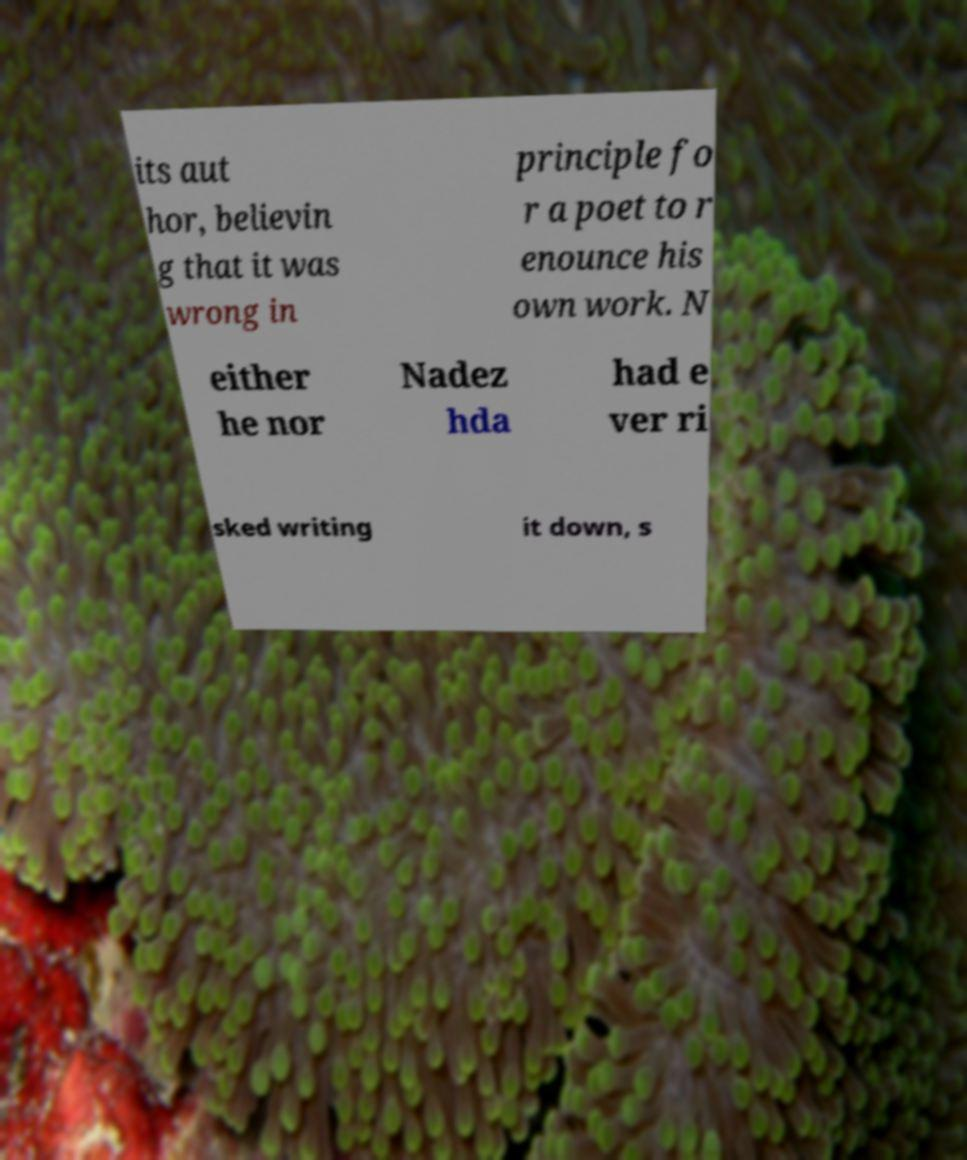What messages or text are displayed in this image? I need them in a readable, typed format. its aut hor, believin g that it was wrong in principle fo r a poet to r enounce his own work. N either he nor Nadez hda had e ver ri sked writing it down, s 